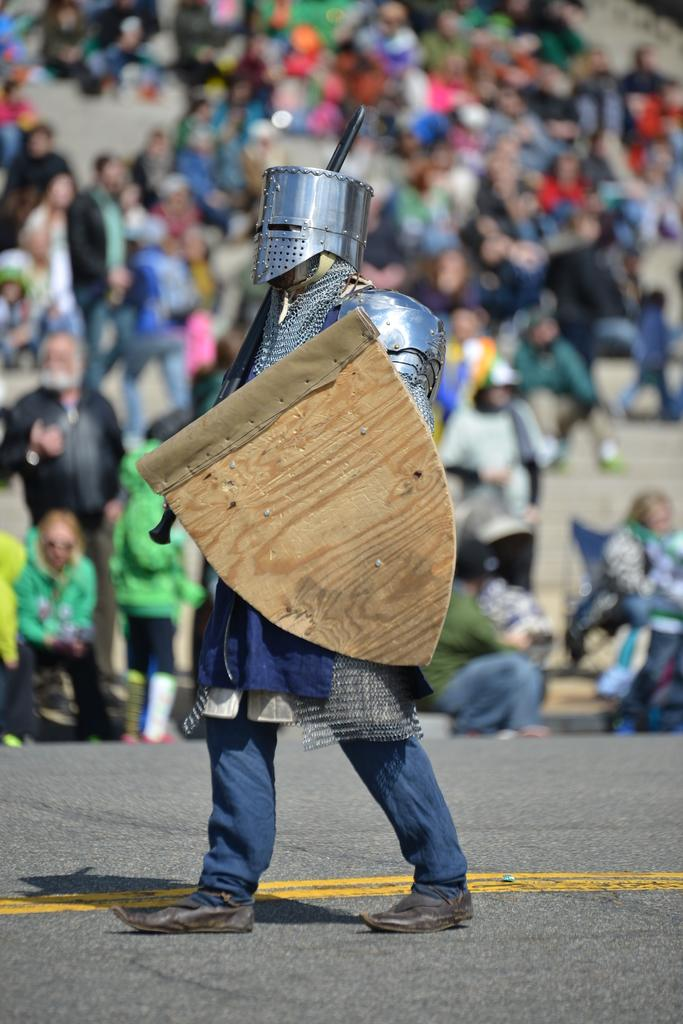What is happening in the image? In the image, there are persons sitting and standing on the floor. Can you describe the person in the foreground? The person in the foreground is wearing armor and holding a stick in their hands. What type of eggs can be seen in the image? There are no eggs present in the image. What activity are the houses participating in within the image? There are no houses present in the image. 